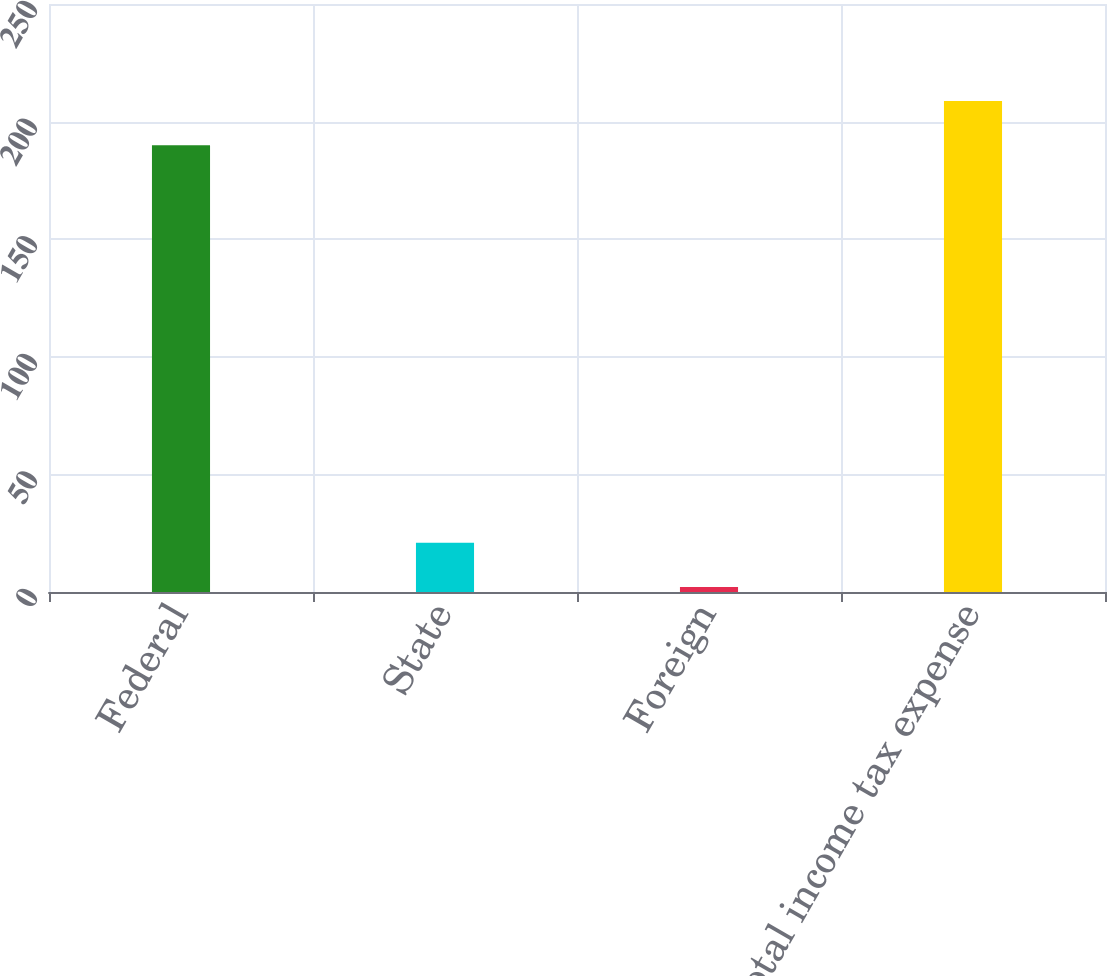Convert chart. <chart><loc_0><loc_0><loc_500><loc_500><bar_chart><fcel>Federal<fcel>State<fcel>Foreign<fcel>Total income tax expense<nl><fcel>189.9<fcel>20.94<fcel>2.1<fcel>208.74<nl></chart> 